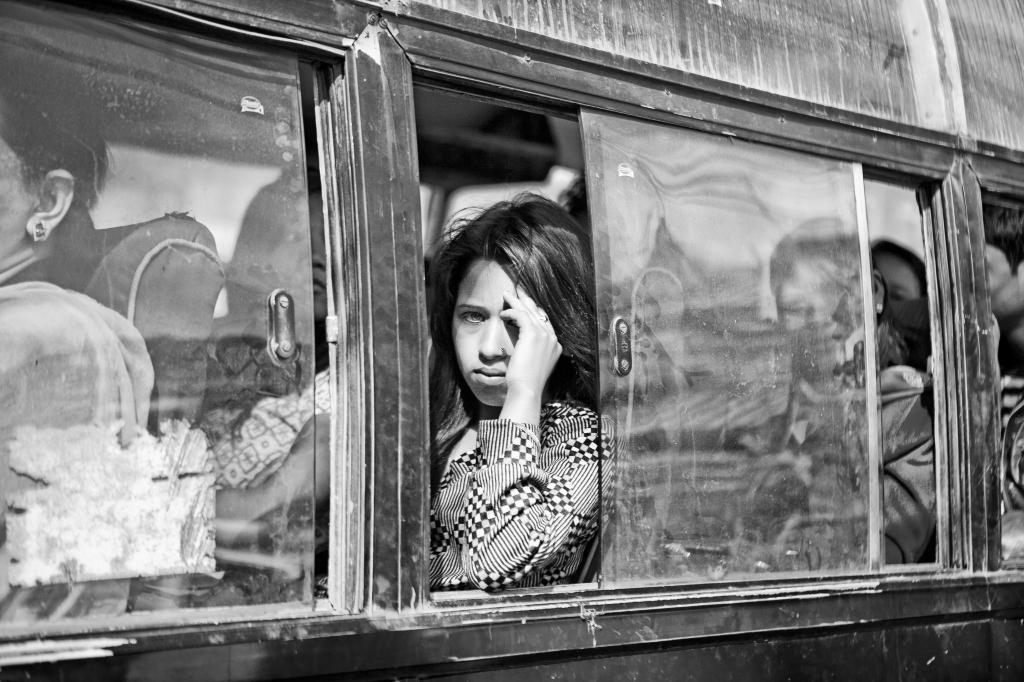What is the color scheme of the image? The image is black and white. What can be seen inside the vehicle in the image? There are passengers sitting in the vehicle. What type of windows does the vehicle have? The vehicle has glass windows. What type of corn is being served by the maid in the image? There is no corn or maid present in the image; it features a black and white image of passengers in a vehicle with glass windows. 